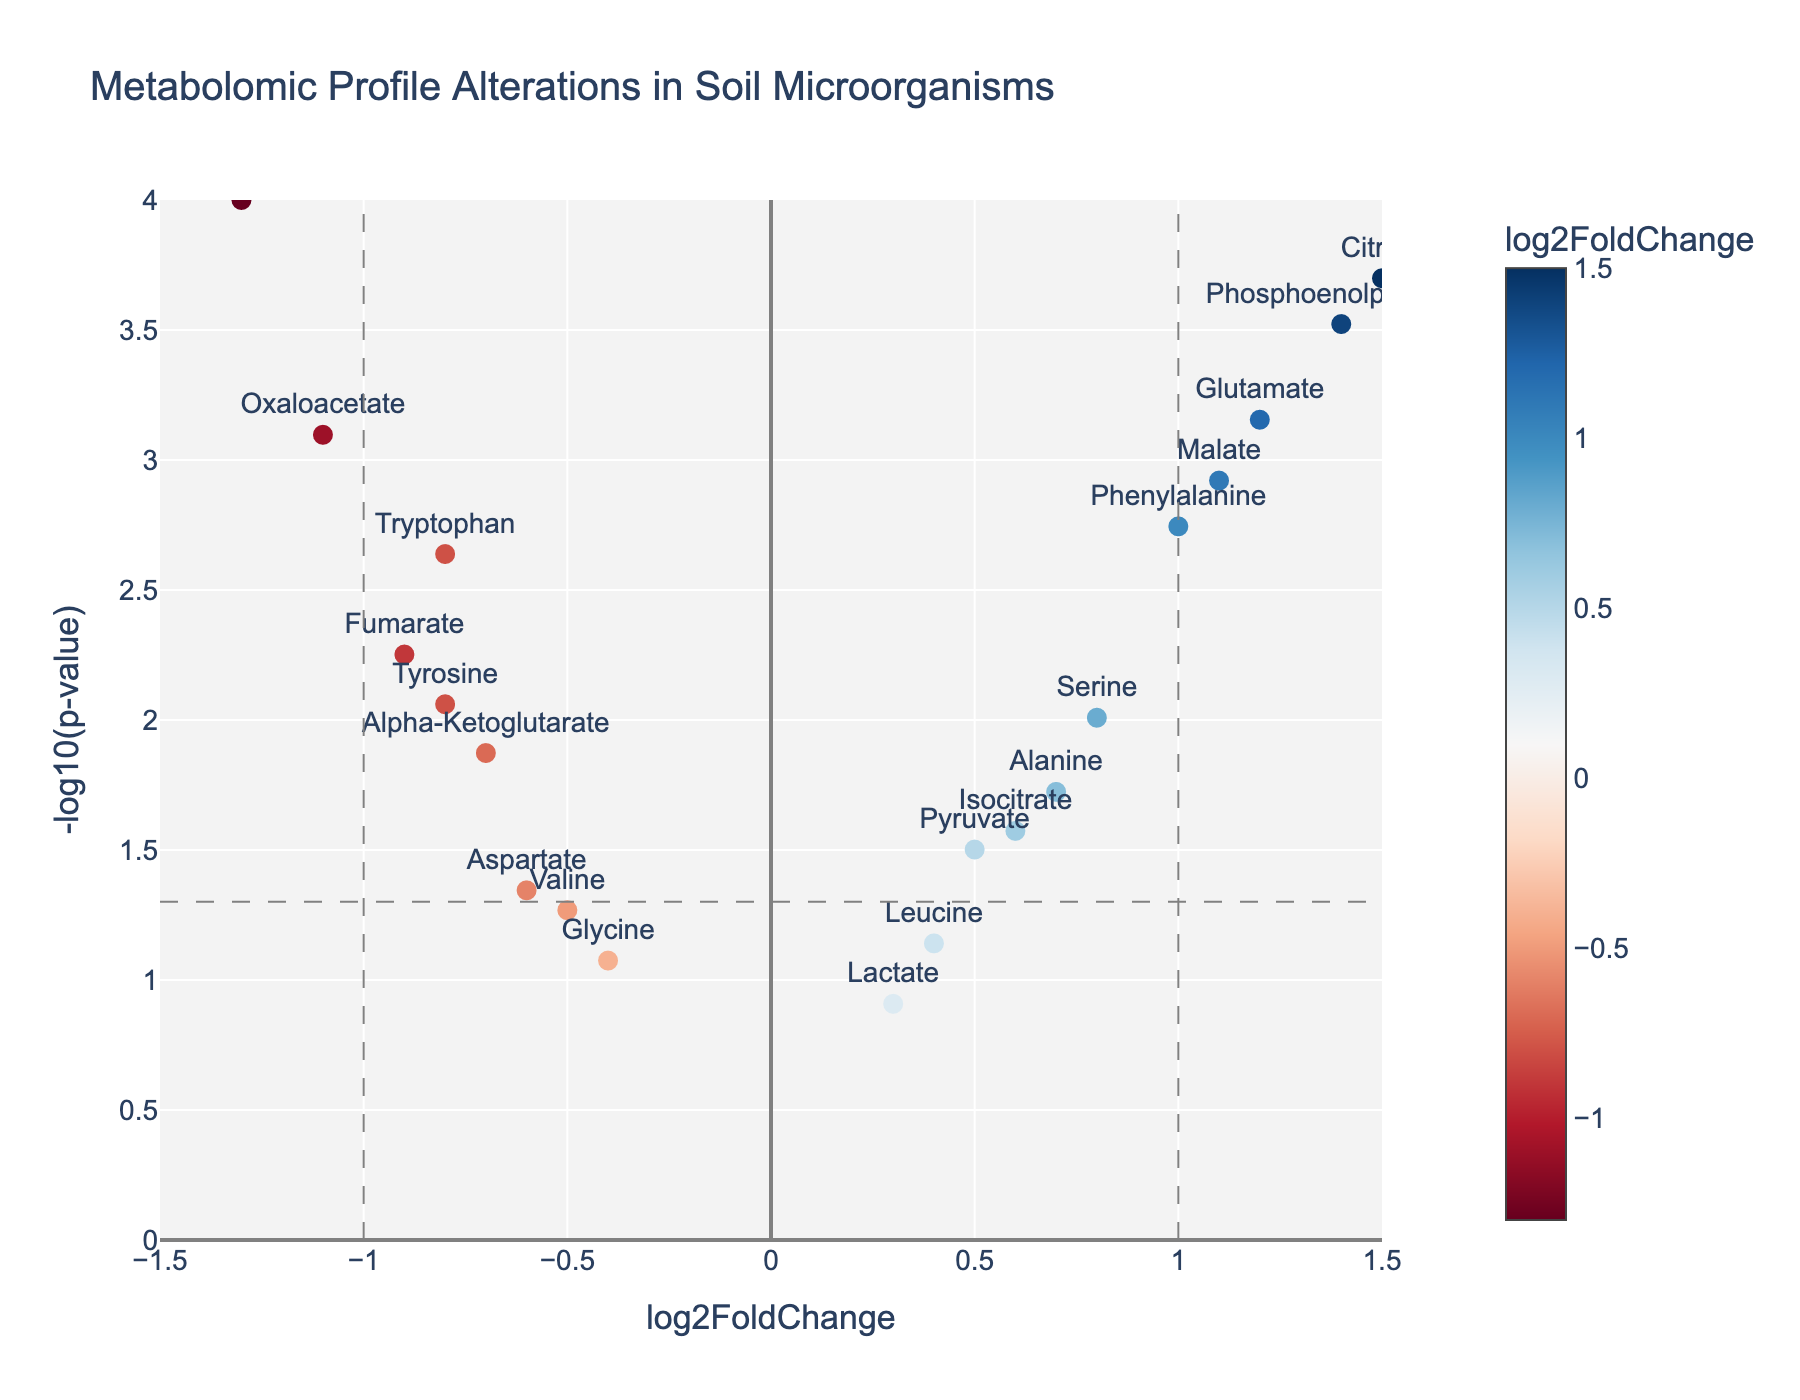What is the title of the plot? The title of the plot is prominently displayed at the top of the figure and can be found as text within the plot area.
Answer: Metabolomic Profile Alterations in Soil Microorganisms How many metabolites have a p-value less than 0.05? The horizontal line represents the p-value threshold of 0.05. We count the number of markers (metabolites) above this line.
Answer: 15 Which metabolite has the highest log2FoldChange value? Locate the metabolite with the highest x-axis value (log2FoldChange) on the right side of the plot and read its label.
Answer: Citrate What is the log2FoldChange value for Succinate? Find the marker labeled "Succinate" and read the x-coordinate value, which represents the log2FoldChange.
Answer: -1.3 How many metabolites have a log2FoldChange greater than 1? Identify the secondary vertical line at x=1 and count the markers to the right of this line.
Answer: 4 Which metabolite has the most statistically significant change? Identify the marker with the highest y-axis value (-log10(p-value)), indicating the smallest p-value.
Answer: Succinate Compare the log2FoldChange values of Glutamate and Alpha-Ketoglutarate. Which one is higher? Find the x-axis values of both "Glutamate" and "Alpha-Ketoglutarate" and compare them. Glutamate has a higher log2FoldChange value.
Answer: Glutamate What does a negative log2FoldChange value indicate about the metabolite level in soil microorganisms? Negative log2FoldChange indicates a decrease in the metabolite level compared to the control.
Answer: Decrease How many metabolites have both a log2FoldChange larger than 0.5 and a p-value less than 0.01? Identify metabolites to the right of log2FoldChange = 0.5 and above the -log10(p-value) = 2, then count these markers.
Answer: 5 What color are the metabolites with negative log2FoldChanges? Observing the color scale indicates that negative log2FoldChanges are represented by shades of blue.
Answer: Blue 